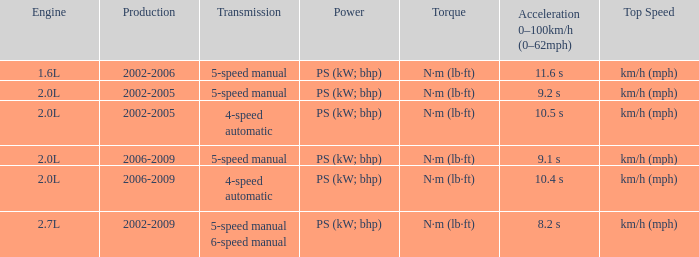What is the top speed of a 4-speed automatic with production in 2002-2005? Km/h (mph). 